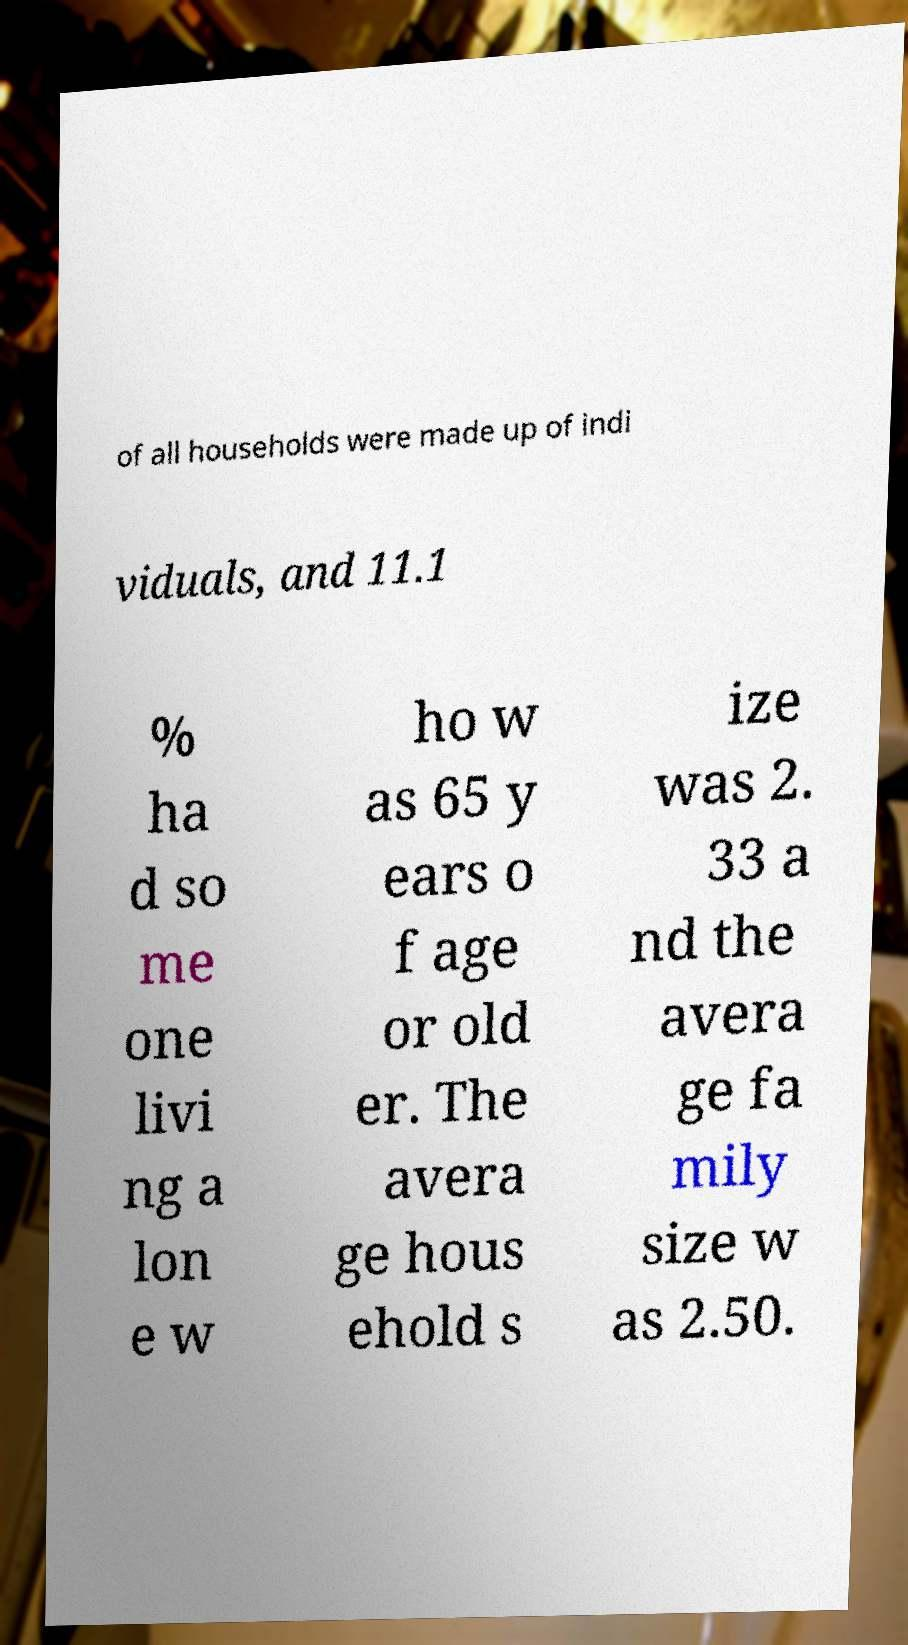I need the written content from this picture converted into text. Can you do that? of all households were made up of indi viduals, and 11.1 % ha d so me one livi ng a lon e w ho w as 65 y ears o f age or old er. The avera ge hous ehold s ize was 2. 33 a nd the avera ge fa mily size w as 2.50. 